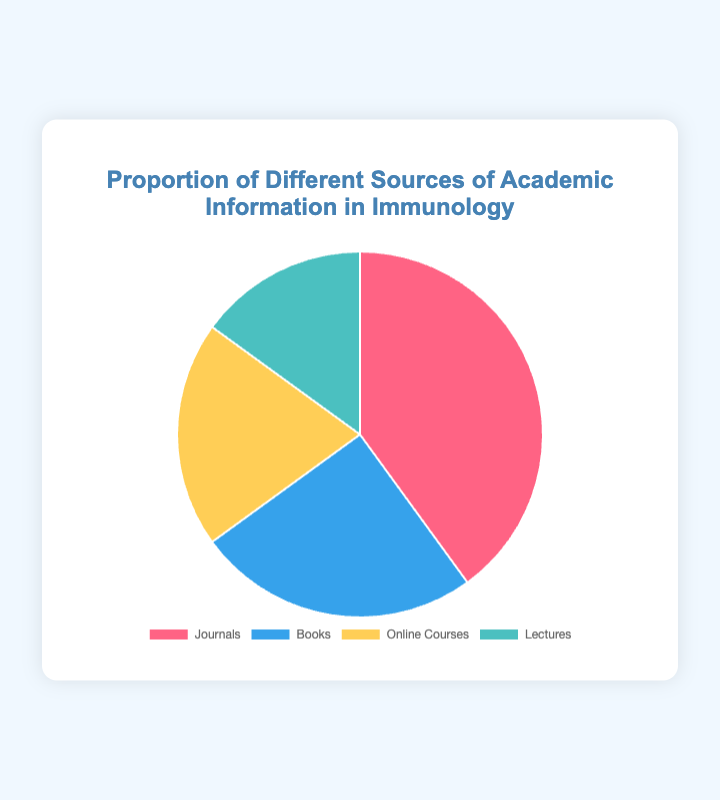What's the largest source of academic information according to the pie chart? The largest section of the pie chart represents the source with the highest proportion. The 'Journals' section is the largest at 40%.
Answer: Journals Which source of academic information has the smallest proportion? The smallest section of the pie chart has the lowest proportion. The 'Lectures' section is the smallest at 15%.
Answer: Lectures What's the combined proportion of Books and Online Courses? Add the proportions of Books (25%) and Online Courses (20%). 25% + 20% = 45%.
Answer: 45% How many more percentage points do Journals have compared to Lectures? Subtract the proportion of Lectures from Journals. 40% - 15% = 25%.
Answer: 25% If the total number of academic sources is 200, how many sources come from Books? Calculate the number using the proportion of Books, which is 25% of 200. (25/100) * 200 = 50.
Answer: 50 Compare the proportions of Online Courses and Lectures. Which one is greater and by how much? Online Courses have 20%, and Lectures have 15%. Subtract the proportions: 20% - 15% = 5%.
Answer: Online Courses, by 5% What is the difference in proportion between the source with the highest usage and the source with the lowest? Subtract the proportion of Lectures (15%) from Journals (40%). 40% - 15% = 25%.
Answer: 25% Which source is represented by the blue-colored section in the pie chart? The visual interpretation shows Books represented by the blue-colored section.
Answer: Books What proportion would be left if Journals and Books were combined together? Add the proportions of Journals (40%) and Books (25%) and then subtract from 100%. 100% - (40% + 25%) = 35%.
Answer: 35% What is the ratio of the proportion of Journals to Online Courses? Divide the proportion of Journals by the proportion of Online Courses. 40% / 20% = 2:1.
Answer: 2:1 